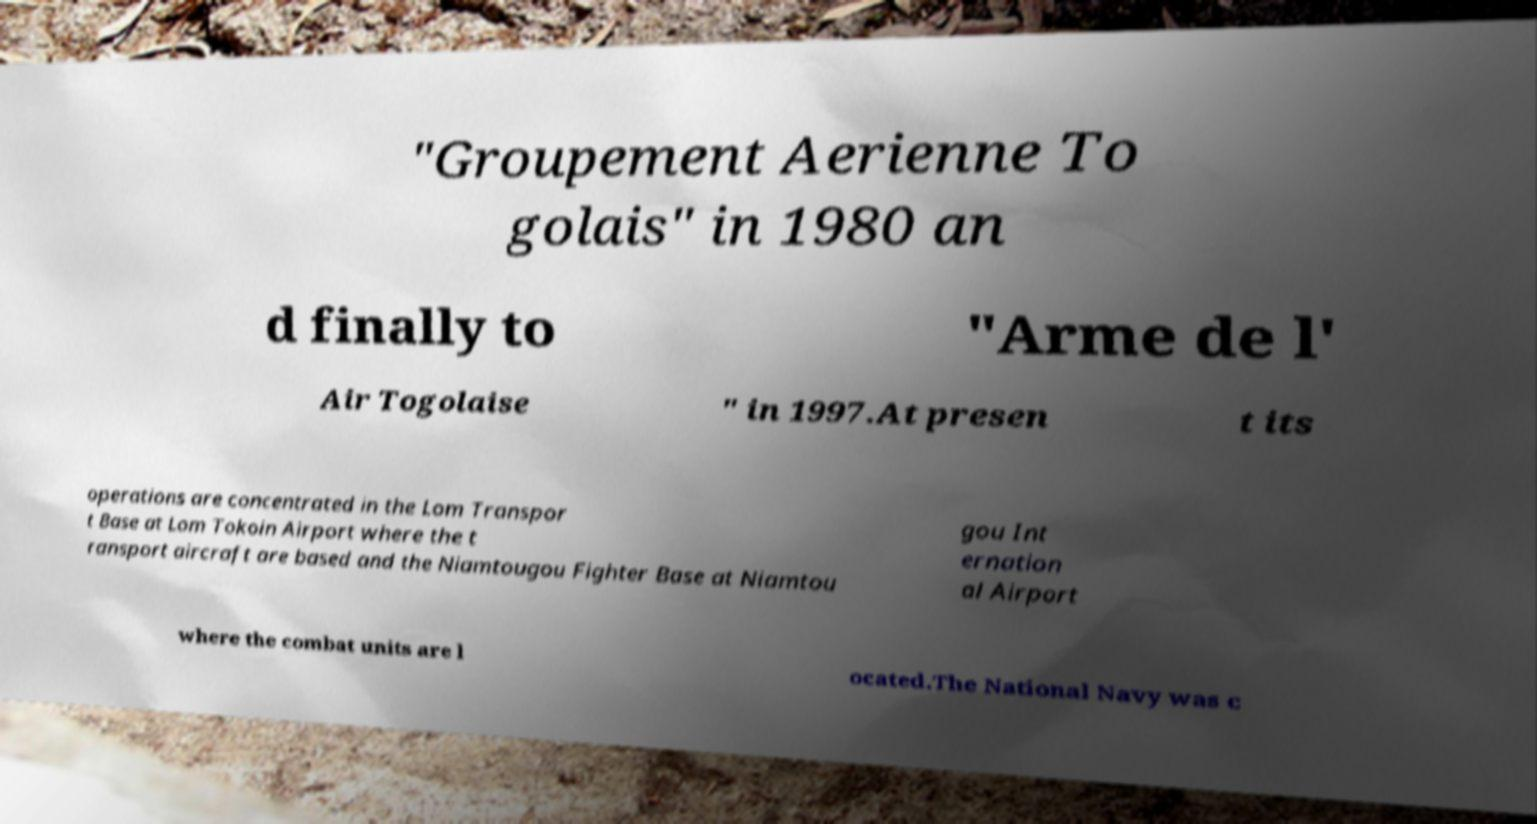Can you accurately transcribe the text from the provided image for me? "Groupement Aerienne To golais" in 1980 an d finally to "Arme de l' Air Togolaise " in 1997.At presen t its operations are concentrated in the Lom Transpor t Base at Lom Tokoin Airport where the t ransport aircraft are based and the Niamtougou Fighter Base at Niamtou gou Int ernation al Airport where the combat units are l ocated.The National Navy was c 